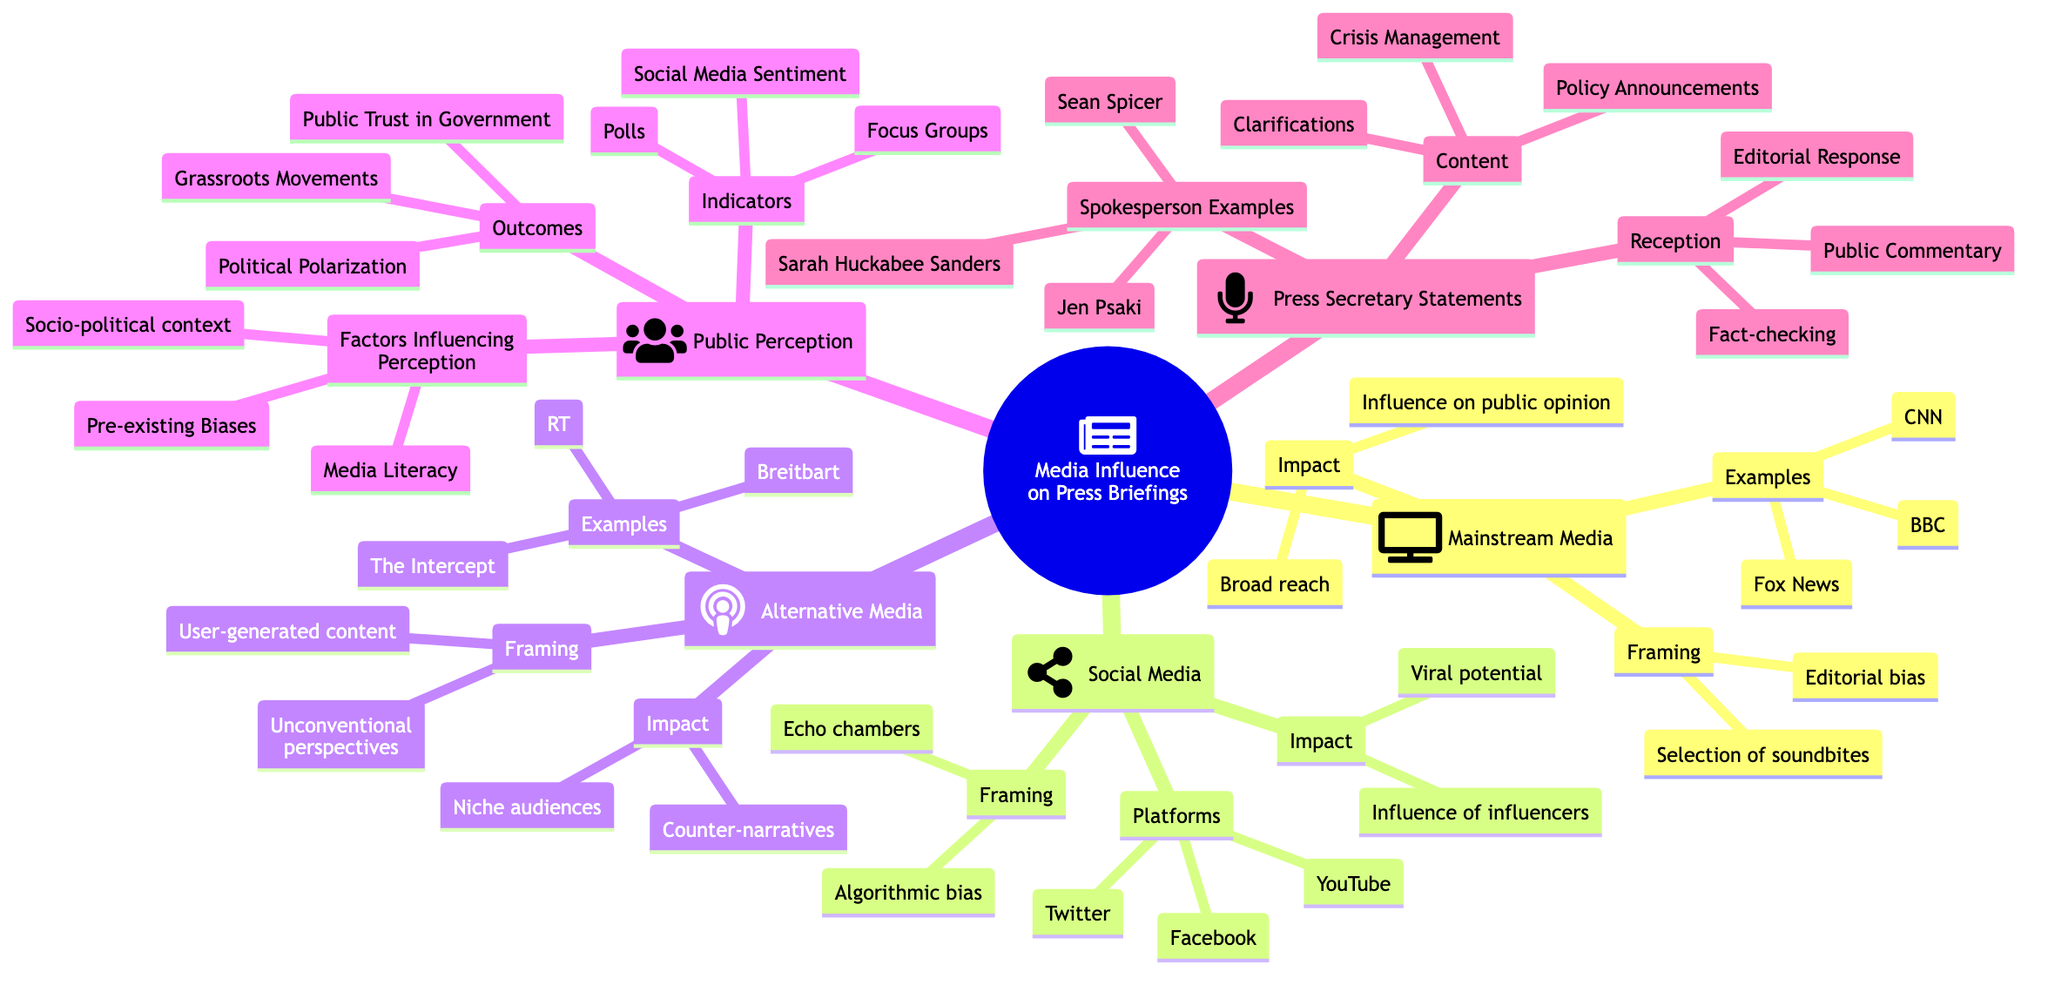What are three examples of mainstream media? The diagram clearly lists three examples under the "Mainstream Media" category: CNN, BBC, and Fox News.
Answer: CNN, BBC, Fox News What is one impact of social media on public perception? The "Impact" section under "Social Media" states "Viral potential" and "Influence of influencers." Hence, "Viral potential" is a valid answer.
Answer: Viral potential How many spokesperson examples are listed under Press Secretary Statements? The diagram includes three spokesperson examples: Jen Psaki, Sarah Huckabee Sanders, and Sean Spicer, which totals three.
Answer: 3 What two factors influence public perception? The diagram shows three factors under "Factors Influencing Perception." I can provide "Media Literacy" and "Pre-existing Biases" as two of them.
Answer: Media Literacy, Pre-existing Biases Which type of media has counter-narratives as an impact? The "Impact" section under "Alternative Media" specifies "Counter-narratives" as one of its impacts. Thus, alternative media is the correct answer.
Answer: Alternative Media What is one indicator for measuring public perception? The diagram includes indicators such as "Polls," "Focus Groups," and "Social Media Sentiment," so any of these can be the answer. Here, "Polls" will be used.
Answer: Polls What relationship is indicated between mainstream media and public opinion? The "Impact" section under "Mainstream Media" directly mentions "Influence on public opinion," indicating a direct relationship between them.
Answer: Influence on public opinion Which media platform is cited for algorithmic bias? The diagram states "Algorithmic bias" under "Framing" in the "Social Media" category; hence, social media platforms are associated with it.
Answer: Social Media What type of responses are outlined under the reception of press secretary statements? The "Reception" section details "Fact-checking," "Editorial Response," and "Public Commentary." Thus, these categories describe the types of responses.
Answer: Fact-checking, Editorial Response, Public Commentary 